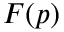Convert formula to latex. <formula><loc_0><loc_0><loc_500><loc_500>F ( p )</formula> 